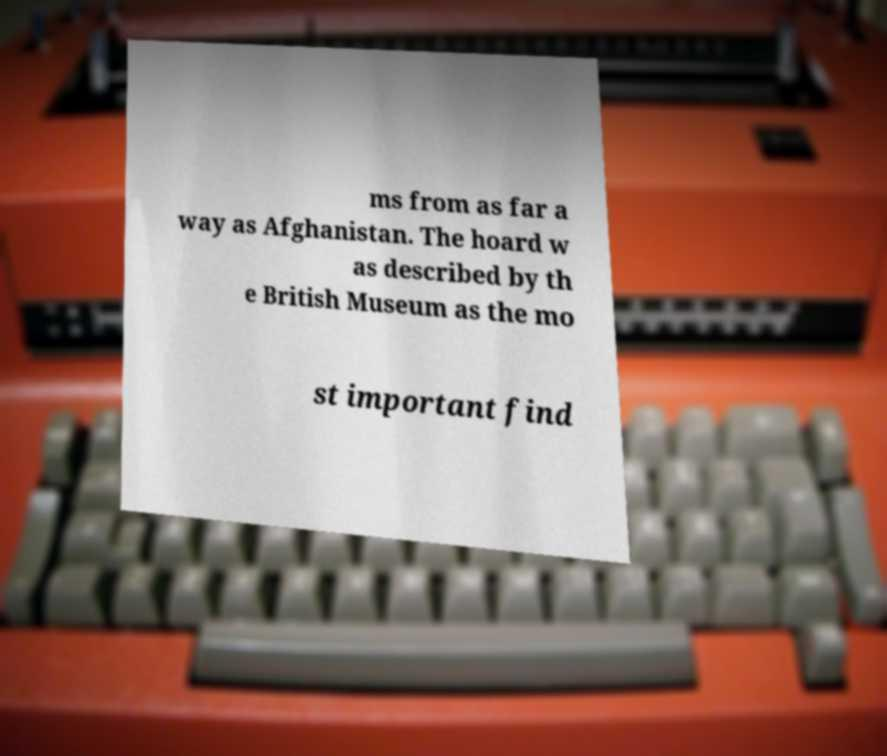Can you accurately transcribe the text from the provided image for me? ms from as far a way as Afghanistan. The hoard w as described by th e British Museum as the mo st important find 